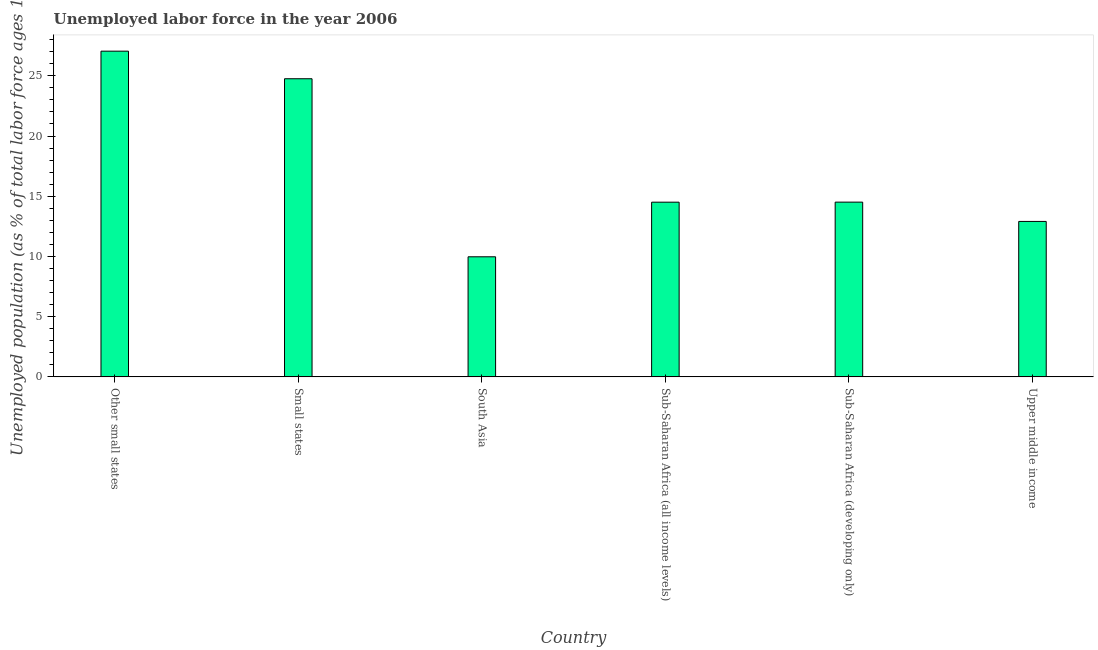What is the title of the graph?
Provide a succinct answer. Unemployed labor force in the year 2006. What is the label or title of the X-axis?
Provide a succinct answer. Country. What is the label or title of the Y-axis?
Your answer should be compact. Unemployed population (as % of total labor force ages 15-24). What is the total unemployed youth population in Small states?
Ensure brevity in your answer.  24.76. Across all countries, what is the maximum total unemployed youth population?
Keep it short and to the point. 27.05. Across all countries, what is the minimum total unemployed youth population?
Provide a short and direct response. 9.97. In which country was the total unemployed youth population maximum?
Provide a succinct answer. Other small states. What is the sum of the total unemployed youth population?
Provide a short and direct response. 103.71. What is the difference between the total unemployed youth population in South Asia and Sub-Saharan Africa (developing only)?
Your answer should be compact. -4.54. What is the average total unemployed youth population per country?
Ensure brevity in your answer.  17.28. What is the median total unemployed youth population?
Your answer should be very brief. 14.51. In how many countries, is the total unemployed youth population greater than 5 %?
Offer a very short reply. 6. What is the ratio of the total unemployed youth population in Other small states to that in Sub-Saharan Africa (developing only)?
Offer a terse response. 1.86. What is the difference between the highest and the second highest total unemployed youth population?
Give a very brief answer. 2.29. What is the difference between the highest and the lowest total unemployed youth population?
Give a very brief answer. 17.08. In how many countries, is the total unemployed youth population greater than the average total unemployed youth population taken over all countries?
Your answer should be compact. 2. How many countries are there in the graph?
Offer a terse response. 6. What is the Unemployed population (as % of total labor force ages 15-24) in Other small states?
Make the answer very short. 27.05. What is the Unemployed population (as % of total labor force ages 15-24) of Small states?
Keep it short and to the point. 24.76. What is the Unemployed population (as % of total labor force ages 15-24) of South Asia?
Provide a succinct answer. 9.97. What is the Unemployed population (as % of total labor force ages 15-24) in Sub-Saharan Africa (all income levels)?
Your response must be concise. 14.51. What is the Unemployed population (as % of total labor force ages 15-24) of Sub-Saharan Africa (developing only)?
Offer a terse response. 14.51. What is the Unemployed population (as % of total labor force ages 15-24) of Upper middle income?
Your answer should be very brief. 12.91. What is the difference between the Unemployed population (as % of total labor force ages 15-24) in Other small states and Small states?
Offer a very short reply. 2.29. What is the difference between the Unemployed population (as % of total labor force ages 15-24) in Other small states and South Asia?
Provide a succinct answer. 17.08. What is the difference between the Unemployed population (as % of total labor force ages 15-24) in Other small states and Sub-Saharan Africa (all income levels)?
Make the answer very short. 12.54. What is the difference between the Unemployed population (as % of total labor force ages 15-24) in Other small states and Sub-Saharan Africa (developing only)?
Offer a terse response. 12.54. What is the difference between the Unemployed population (as % of total labor force ages 15-24) in Other small states and Upper middle income?
Provide a short and direct response. 14.14. What is the difference between the Unemployed population (as % of total labor force ages 15-24) in Small states and South Asia?
Make the answer very short. 14.79. What is the difference between the Unemployed population (as % of total labor force ages 15-24) in Small states and Sub-Saharan Africa (all income levels)?
Provide a succinct answer. 10.25. What is the difference between the Unemployed population (as % of total labor force ages 15-24) in Small states and Sub-Saharan Africa (developing only)?
Ensure brevity in your answer.  10.25. What is the difference between the Unemployed population (as % of total labor force ages 15-24) in Small states and Upper middle income?
Your answer should be very brief. 11.85. What is the difference between the Unemployed population (as % of total labor force ages 15-24) in South Asia and Sub-Saharan Africa (all income levels)?
Your response must be concise. -4.54. What is the difference between the Unemployed population (as % of total labor force ages 15-24) in South Asia and Sub-Saharan Africa (developing only)?
Offer a very short reply. -4.54. What is the difference between the Unemployed population (as % of total labor force ages 15-24) in South Asia and Upper middle income?
Make the answer very short. -2.94. What is the difference between the Unemployed population (as % of total labor force ages 15-24) in Sub-Saharan Africa (all income levels) and Sub-Saharan Africa (developing only)?
Make the answer very short. -0. What is the difference between the Unemployed population (as % of total labor force ages 15-24) in Sub-Saharan Africa (all income levels) and Upper middle income?
Make the answer very short. 1.6. What is the difference between the Unemployed population (as % of total labor force ages 15-24) in Sub-Saharan Africa (developing only) and Upper middle income?
Your response must be concise. 1.6. What is the ratio of the Unemployed population (as % of total labor force ages 15-24) in Other small states to that in Small states?
Ensure brevity in your answer.  1.09. What is the ratio of the Unemployed population (as % of total labor force ages 15-24) in Other small states to that in South Asia?
Keep it short and to the point. 2.71. What is the ratio of the Unemployed population (as % of total labor force ages 15-24) in Other small states to that in Sub-Saharan Africa (all income levels)?
Offer a very short reply. 1.86. What is the ratio of the Unemployed population (as % of total labor force ages 15-24) in Other small states to that in Sub-Saharan Africa (developing only)?
Your answer should be compact. 1.86. What is the ratio of the Unemployed population (as % of total labor force ages 15-24) in Other small states to that in Upper middle income?
Ensure brevity in your answer.  2.1. What is the ratio of the Unemployed population (as % of total labor force ages 15-24) in Small states to that in South Asia?
Keep it short and to the point. 2.48. What is the ratio of the Unemployed population (as % of total labor force ages 15-24) in Small states to that in Sub-Saharan Africa (all income levels)?
Provide a succinct answer. 1.71. What is the ratio of the Unemployed population (as % of total labor force ages 15-24) in Small states to that in Sub-Saharan Africa (developing only)?
Provide a succinct answer. 1.71. What is the ratio of the Unemployed population (as % of total labor force ages 15-24) in Small states to that in Upper middle income?
Offer a very short reply. 1.92. What is the ratio of the Unemployed population (as % of total labor force ages 15-24) in South Asia to that in Sub-Saharan Africa (all income levels)?
Ensure brevity in your answer.  0.69. What is the ratio of the Unemployed population (as % of total labor force ages 15-24) in South Asia to that in Sub-Saharan Africa (developing only)?
Your response must be concise. 0.69. What is the ratio of the Unemployed population (as % of total labor force ages 15-24) in South Asia to that in Upper middle income?
Provide a short and direct response. 0.77. What is the ratio of the Unemployed population (as % of total labor force ages 15-24) in Sub-Saharan Africa (all income levels) to that in Sub-Saharan Africa (developing only)?
Provide a succinct answer. 1. What is the ratio of the Unemployed population (as % of total labor force ages 15-24) in Sub-Saharan Africa (all income levels) to that in Upper middle income?
Give a very brief answer. 1.12. What is the ratio of the Unemployed population (as % of total labor force ages 15-24) in Sub-Saharan Africa (developing only) to that in Upper middle income?
Your answer should be very brief. 1.12. 